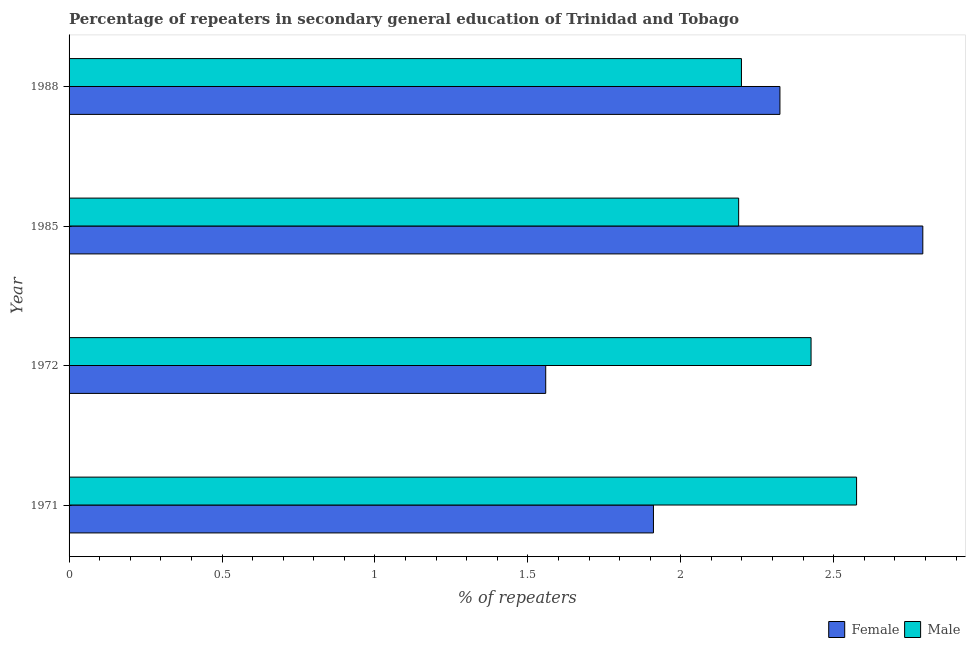How many groups of bars are there?
Provide a succinct answer. 4. Are the number of bars per tick equal to the number of legend labels?
Keep it short and to the point. Yes. Are the number of bars on each tick of the Y-axis equal?
Make the answer very short. Yes. How many bars are there on the 1st tick from the top?
Provide a succinct answer. 2. How many bars are there on the 3rd tick from the bottom?
Ensure brevity in your answer.  2. What is the label of the 4th group of bars from the top?
Your answer should be compact. 1971. In how many cases, is the number of bars for a given year not equal to the number of legend labels?
Offer a very short reply. 0. What is the percentage of female repeaters in 1972?
Ensure brevity in your answer.  1.56. Across all years, what is the maximum percentage of male repeaters?
Offer a terse response. 2.57. Across all years, what is the minimum percentage of female repeaters?
Provide a short and direct response. 1.56. In which year was the percentage of female repeaters maximum?
Your answer should be compact. 1985. In which year was the percentage of female repeaters minimum?
Offer a very short reply. 1972. What is the total percentage of male repeaters in the graph?
Your answer should be very brief. 9.39. What is the difference between the percentage of male repeaters in 1985 and that in 1988?
Keep it short and to the point. -0.01. What is the difference between the percentage of male repeaters in 1972 and the percentage of female repeaters in 1988?
Make the answer very short. 0.1. What is the average percentage of male repeaters per year?
Make the answer very short. 2.35. In the year 1972, what is the difference between the percentage of female repeaters and percentage of male repeaters?
Provide a succinct answer. -0.87. What is the ratio of the percentage of male repeaters in 1972 to that in 1985?
Offer a very short reply. 1.11. Is the percentage of female repeaters in 1972 less than that in 1988?
Provide a short and direct response. Yes. What is the difference between the highest and the second highest percentage of male repeaters?
Your answer should be compact. 0.15. What is the difference between the highest and the lowest percentage of male repeaters?
Your response must be concise. 0.39. What does the 2nd bar from the bottom in 1985 represents?
Your answer should be compact. Male. How many bars are there?
Offer a terse response. 8. Are all the bars in the graph horizontal?
Your answer should be very brief. Yes. What is the difference between two consecutive major ticks on the X-axis?
Provide a short and direct response. 0.5. Are the values on the major ticks of X-axis written in scientific E-notation?
Your answer should be compact. No. Where does the legend appear in the graph?
Offer a very short reply. Bottom right. How are the legend labels stacked?
Offer a terse response. Horizontal. What is the title of the graph?
Your response must be concise. Percentage of repeaters in secondary general education of Trinidad and Tobago. What is the label or title of the X-axis?
Your answer should be compact. % of repeaters. What is the % of repeaters of Female in 1971?
Give a very brief answer. 1.91. What is the % of repeaters of Male in 1971?
Provide a succinct answer. 2.57. What is the % of repeaters in Female in 1972?
Provide a succinct answer. 1.56. What is the % of repeaters of Male in 1972?
Ensure brevity in your answer.  2.43. What is the % of repeaters in Female in 1985?
Keep it short and to the point. 2.79. What is the % of repeaters in Male in 1985?
Make the answer very short. 2.19. What is the % of repeaters of Female in 1988?
Keep it short and to the point. 2.32. What is the % of repeaters of Male in 1988?
Offer a terse response. 2.2. Across all years, what is the maximum % of repeaters of Female?
Your answer should be very brief. 2.79. Across all years, what is the maximum % of repeaters in Male?
Your answer should be very brief. 2.57. Across all years, what is the minimum % of repeaters in Female?
Ensure brevity in your answer.  1.56. Across all years, what is the minimum % of repeaters in Male?
Your answer should be very brief. 2.19. What is the total % of repeaters in Female in the graph?
Your response must be concise. 8.58. What is the total % of repeaters in Male in the graph?
Offer a very short reply. 9.39. What is the difference between the % of repeaters of Female in 1971 and that in 1972?
Make the answer very short. 0.35. What is the difference between the % of repeaters in Male in 1971 and that in 1972?
Make the answer very short. 0.15. What is the difference between the % of repeaters of Female in 1971 and that in 1985?
Offer a very short reply. -0.88. What is the difference between the % of repeaters of Male in 1971 and that in 1985?
Offer a very short reply. 0.39. What is the difference between the % of repeaters of Female in 1971 and that in 1988?
Offer a very short reply. -0.41. What is the difference between the % of repeaters in Male in 1971 and that in 1988?
Offer a very short reply. 0.38. What is the difference between the % of repeaters of Female in 1972 and that in 1985?
Offer a very short reply. -1.23. What is the difference between the % of repeaters in Male in 1972 and that in 1985?
Give a very brief answer. 0.24. What is the difference between the % of repeaters in Female in 1972 and that in 1988?
Your answer should be very brief. -0.77. What is the difference between the % of repeaters of Male in 1972 and that in 1988?
Your answer should be very brief. 0.23. What is the difference between the % of repeaters in Female in 1985 and that in 1988?
Provide a short and direct response. 0.47. What is the difference between the % of repeaters of Male in 1985 and that in 1988?
Your answer should be very brief. -0.01. What is the difference between the % of repeaters in Female in 1971 and the % of repeaters in Male in 1972?
Make the answer very short. -0.52. What is the difference between the % of repeaters of Female in 1971 and the % of repeaters of Male in 1985?
Make the answer very short. -0.28. What is the difference between the % of repeaters of Female in 1971 and the % of repeaters of Male in 1988?
Your answer should be compact. -0.29. What is the difference between the % of repeaters in Female in 1972 and the % of repeaters in Male in 1985?
Make the answer very short. -0.63. What is the difference between the % of repeaters in Female in 1972 and the % of repeaters in Male in 1988?
Keep it short and to the point. -0.64. What is the difference between the % of repeaters of Female in 1985 and the % of repeaters of Male in 1988?
Offer a very short reply. 0.59. What is the average % of repeaters of Female per year?
Provide a short and direct response. 2.15. What is the average % of repeaters in Male per year?
Your answer should be very brief. 2.35. In the year 1971, what is the difference between the % of repeaters of Female and % of repeaters of Male?
Make the answer very short. -0.66. In the year 1972, what is the difference between the % of repeaters in Female and % of repeaters in Male?
Offer a very short reply. -0.87. In the year 1985, what is the difference between the % of repeaters of Female and % of repeaters of Male?
Your response must be concise. 0.6. In the year 1988, what is the difference between the % of repeaters of Female and % of repeaters of Male?
Ensure brevity in your answer.  0.13. What is the ratio of the % of repeaters in Female in 1971 to that in 1972?
Provide a short and direct response. 1.23. What is the ratio of the % of repeaters of Male in 1971 to that in 1972?
Offer a very short reply. 1.06. What is the ratio of the % of repeaters of Female in 1971 to that in 1985?
Make the answer very short. 0.68. What is the ratio of the % of repeaters of Male in 1971 to that in 1985?
Offer a very short reply. 1.18. What is the ratio of the % of repeaters in Female in 1971 to that in 1988?
Ensure brevity in your answer.  0.82. What is the ratio of the % of repeaters of Male in 1971 to that in 1988?
Your response must be concise. 1.17. What is the ratio of the % of repeaters in Female in 1972 to that in 1985?
Keep it short and to the point. 0.56. What is the ratio of the % of repeaters in Male in 1972 to that in 1985?
Provide a succinct answer. 1.11. What is the ratio of the % of repeaters of Female in 1972 to that in 1988?
Keep it short and to the point. 0.67. What is the ratio of the % of repeaters of Male in 1972 to that in 1988?
Provide a succinct answer. 1.1. What is the ratio of the % of repeaters of Female in 1985 to that in 1988?
Make the answer very short. 1.2. What is the difference between the highest and the second highest % of repeaters of Female?
Offer a terse response. 0.47. What is the difference between the highest and the second highest % of repeaters of Male?
Give a very brief answer. 0.15. What is the difference between the highest and the lowest % of repeaters in Female?
Give a very brief answer. 1.23. What is the difference between the highest and the lowest % of repeaters of Male?
Provide a short and direct response. 0.39. 